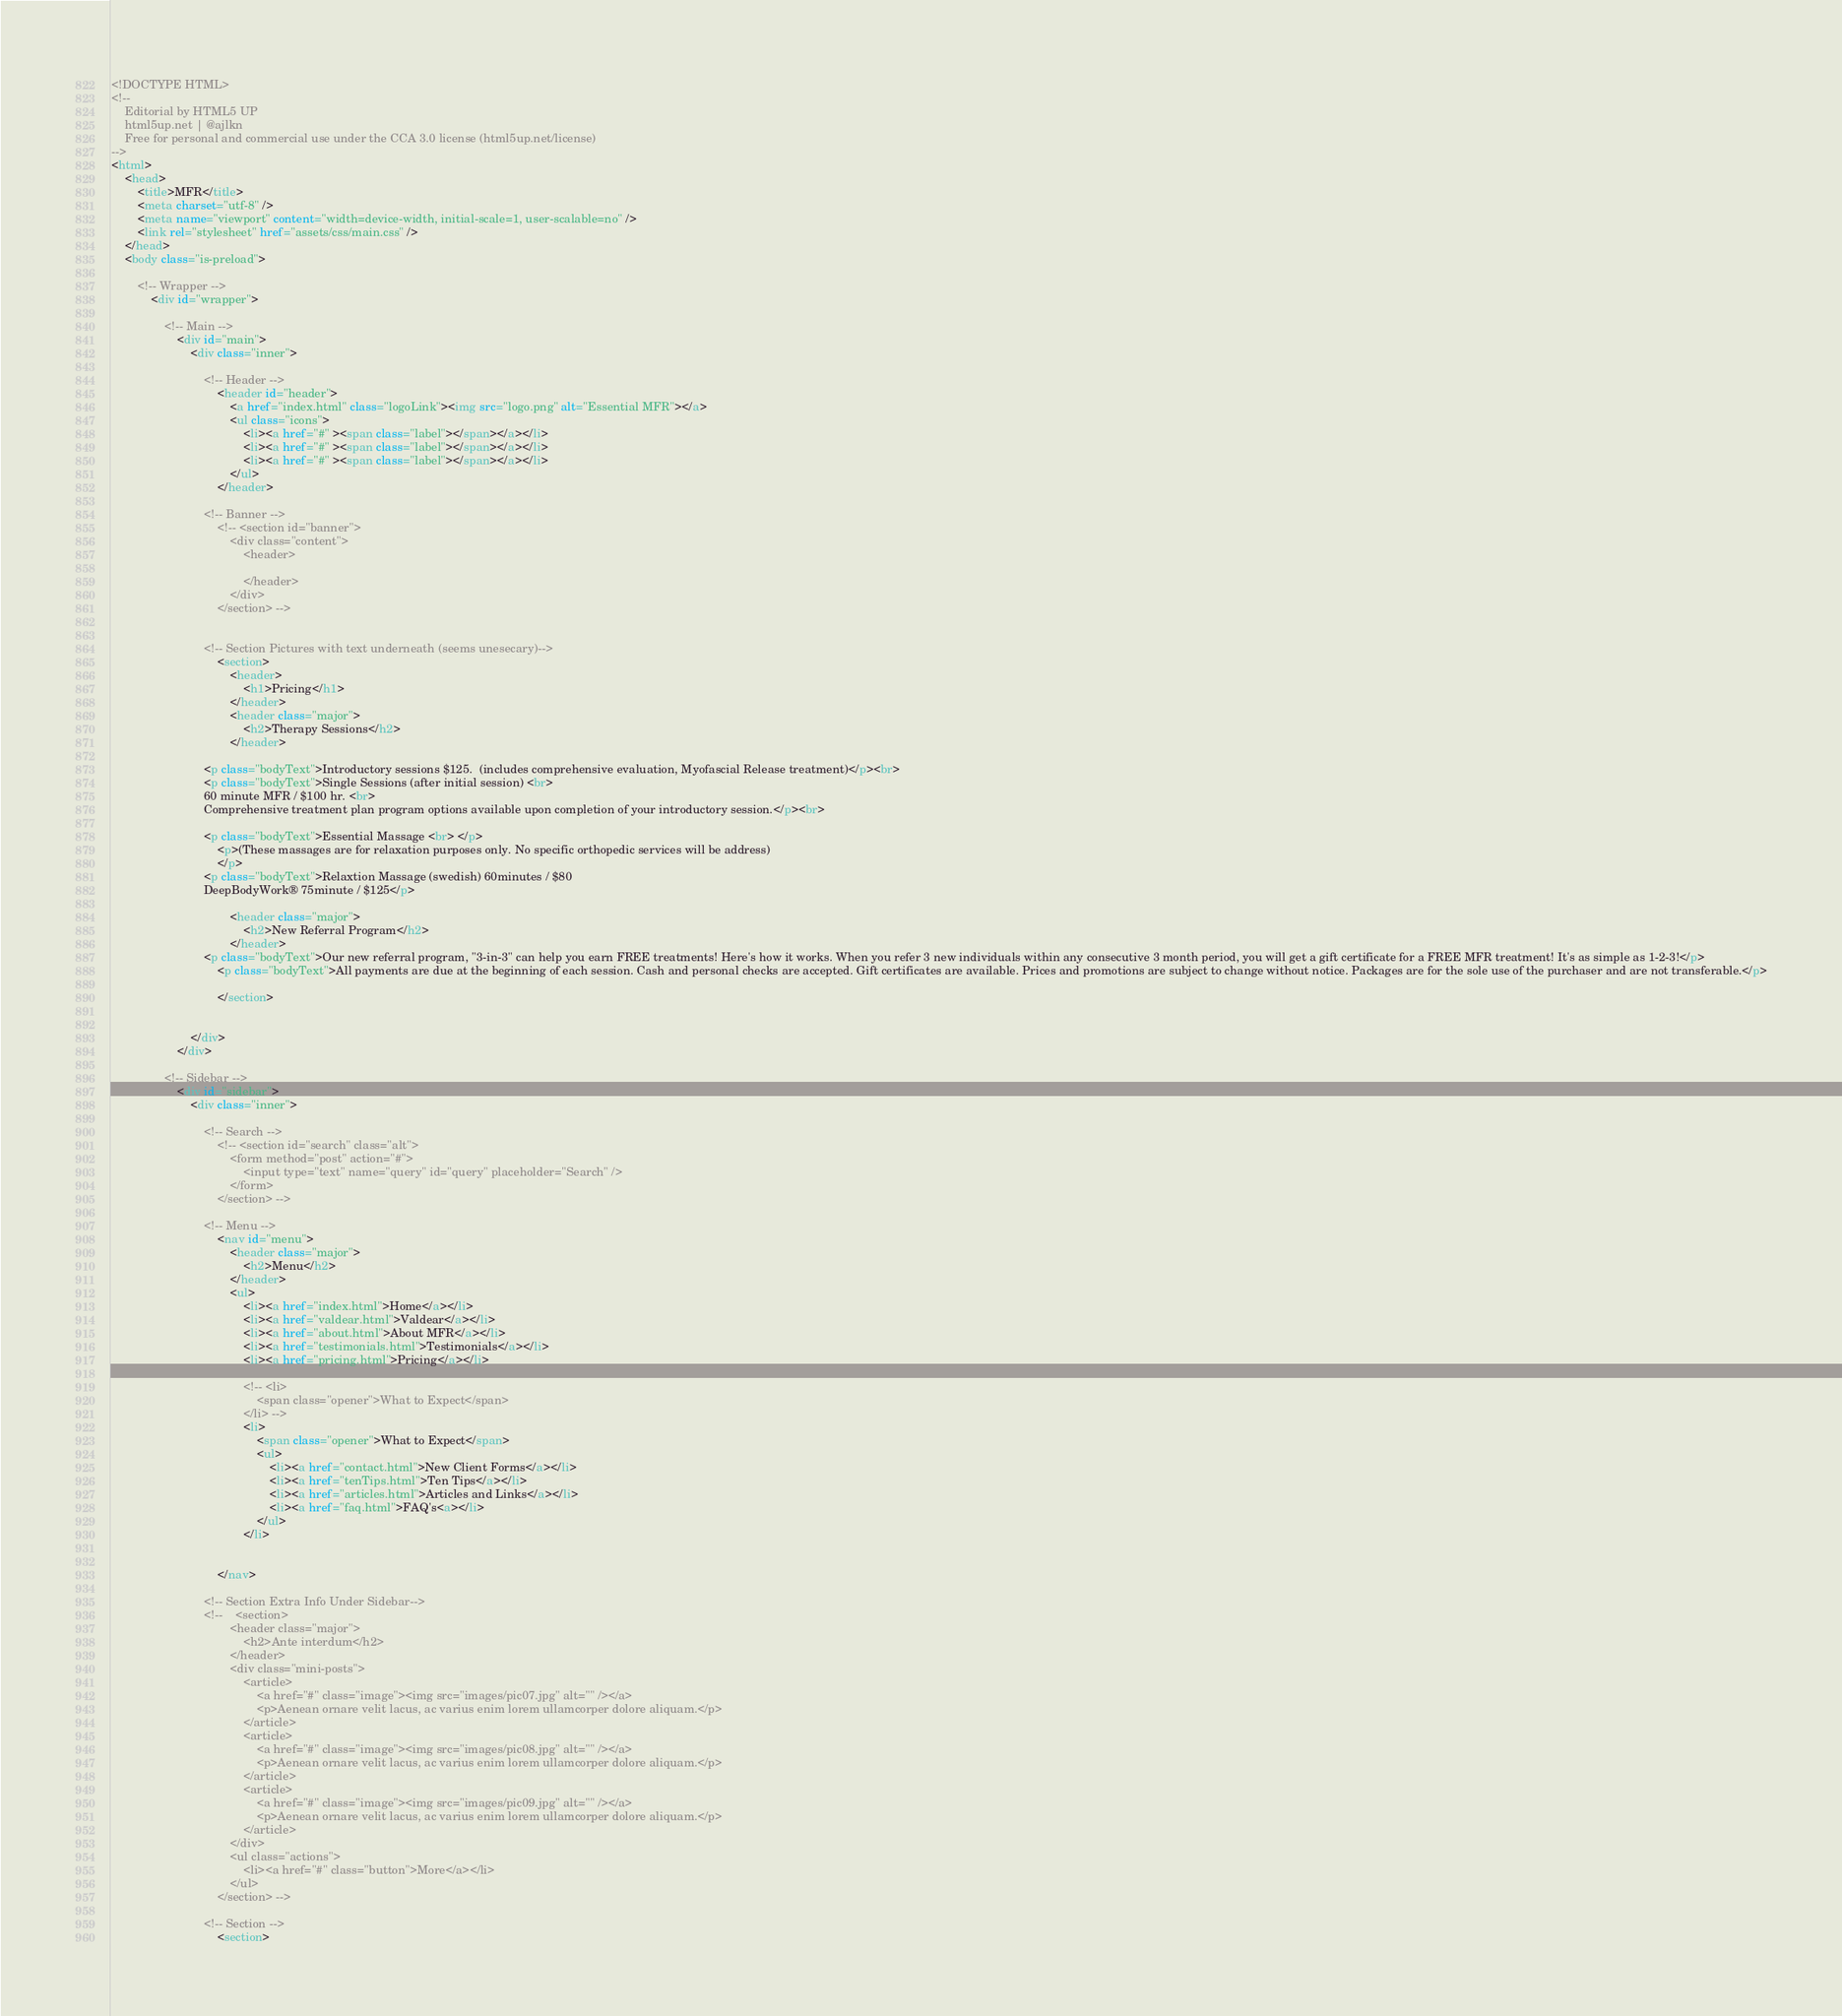<code> <loc_0><loc_0><loc_500><loc_500><_HTML_><!DOCTYPE HTML>
<!--
	Editorial by HTML5 UP
	html5up.net | @ajlkn
	Free for personal and commercial use under the CCA 3.0 license (html5up.net/license)
-->
<html>
	<head>
		<title>MFR</title>
		<meta charset="utf-8" />
		<meta name="viewport" content="width=device-width, initial-scale=1, user-scalable=no" />
		<link rel="stylesheet" href="assets/css/main.css" />
	</head>
	<body class="is-preload">

		<!-- Wrapper -->
			<div id="wrapper">

				<!-- Main -->
					<div id="main">
						<div class="inner">

							<!-- Header -->
								<header id="header">
									<a href="index.html" class="logoLink"><img src="logo.png" alt="Essential MFR"></a>
									<ul class="icons">
										<li><a href="#" ><span class="label"></span></a></li>
										<li><a href="#" ><span class="label"></span></a></li>
										<li><a href="#" ><span class="label"></span></a></li>
									</ul>
								</header>

							<!-- Banner -->
								<!-- <section id="banner">
									<div class="content">
										<header>
											
										</header>
 									</div>
								</section> -->

							
							<!-- Section Pictures with text underneath (seems unesecary)-->
								<section>
									<header>
										<h1>Pricing</h1>
									</header>
									<header class="major">
										<h2>Therapy Sessions</h2>
									</header>

							<p class="bodyText">Introductory sessions $125.  (includes comprehensive evaluation, Myofascial Release treatment)</p><br>
							<p class="bodyText">Single Sessions (after initial session) <br>
							60 minute MFR / $100 hr. <br>
							Comprehensive treatment plan program options available upon completion of your introductory session.</p><br>

							<p class="bodyText">Essential Massage <br> </p>
								<p>(These massages are for relaxation purposes only. No specific orthopedic services will be address)
								</p>
							<p class="bodyText">Relaxtion Massage (swedish) 60minutes / $80 
							DeepBodyWork® 75minute / $125</p>

									<header class="major">
										<h2>New Referral Program</h2>
									</header>
							<p class="bodyText">Our new referral program, "3-in-3" can help you earn FREE treatments! Here's how it works. When you refer 3 new individuals within any consecutive 3 month period, you will get a gift certificate for a FREE MFR treatment! It's as simple as 1-2-3!</p>
								<p class="bodyText">All payments are due at the beginning of each session. Cash and personal checks are accepted. Gift certificates are available. Prices and promotions are subject to change without notice. Packages are for the sole use of the purchaser and are not transferable.</p>

								</section>


						</div>
					</div>

				<!-- Sidebar -->
					<div id="sidebar">
						<div class="inner">

							<!-- Search -->
								<!-- <section id="search" class="alt">
									<form method="post" action="#">
										<input type="text" name="query" id="query" placeholder="Search" />
									</form>
								</section> -->

							<!-- Menu -->
								<nav id="menu">
									<header class="major">
										<h2>Menu</h2>
									</header>
									<ul>
										<li><a href="index.html">Home</a></li>
										<li><a href="valdear.html">Valdear</a></li>
										<li><a href="about.html">About MFR</a></li>
										<li><a href="testimonials.html">Testimonials</a></li>
										<li><a href="pricing.html">Pricing</a></li>

										<!-- <li>
											<span class="opener">What to Expect</span>
										</li> -->
										<li>
											<span class="opener">What to Expect</span>
											<ul>
												<li><a href="contact.html">New Client Forms</a></li>
												<li><a href="tenTips.html">Ten Tips</a></li>
												<li><a href="articles.html">Articles and Links</a></li>									
												<li><a href="faq.html">FAQ's<a></li>
											</ul>
										</li>
										
								
								</nav>

							<!-- Section Extra Info Under Sidebar-->
							<!-- 	<section>
									<header class="major">
										<h2>Ante interdum</h2>
									</header>
									<div class="mini-posts">
										<article>
											<a href="#" class="image"><img src="images/pic07.jpg" alt="" /></a>
											<p>Aenean ornare velit lacus, ac varius enim lorem ullamcorper dolore aliquam.</p>
										</article>
										<article>
											<a href="#" class="image"><img src="images/pic08.jpg" alt="" /></a>
											<p>Aenean ornare velit lacus, ac varius enim lorem ullamcorper dolore aliquam.</p>
										</article>
										<article>
											<a href="#" class="image"><img src="images/pic09.jpg" alt="" /></a>
											<p>Aenean ornare velit lacus, ac varius enim lorem ullamcorper dolore aliquam.</p>
										</article>
									</div>
									<ul class="actions">
										<li><a href="#" class="button">More</a></li>
									</ul>
								</section> -->

							<!-- Section -->
								<section></code> 